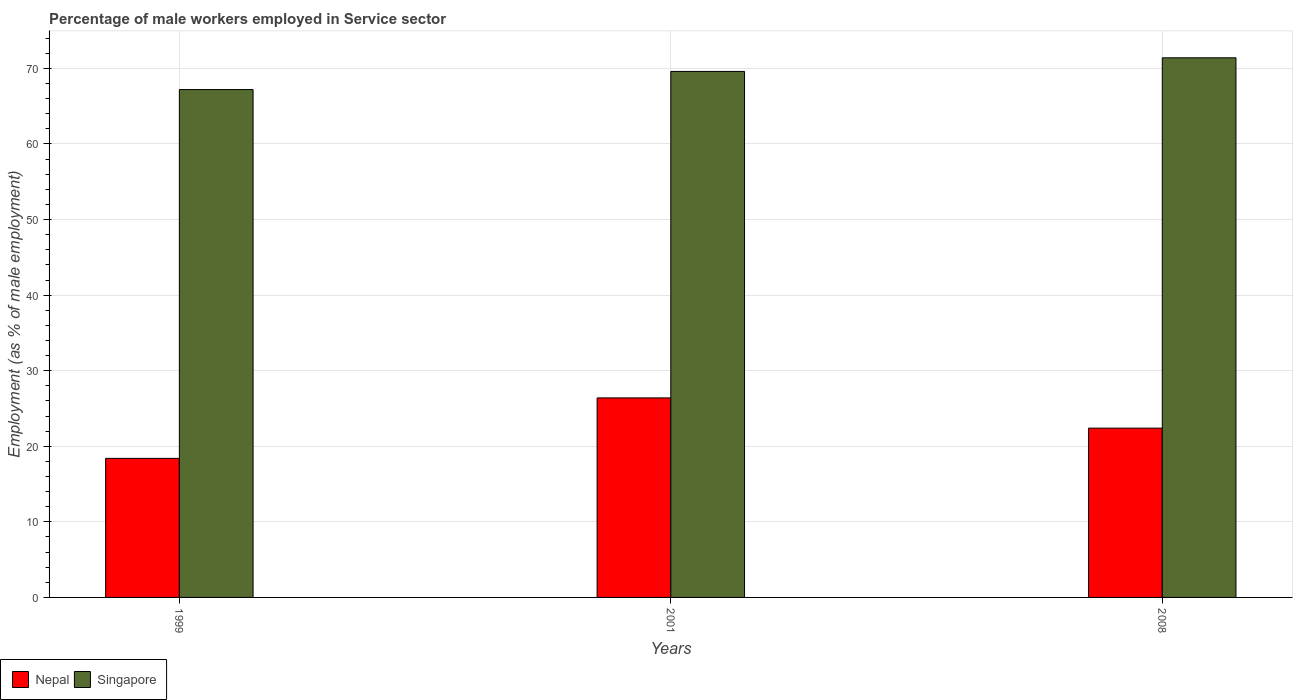How many groups of bars are there?
Your answer should be compact. 3. Are the number of bars per tick equal to the number of legend labels?
Keep it short and to the point. Yes. Are the number of bars on each tick of the X-axis equal?
Keep it short and to the point. Yes. How many bars are there on the 2nd tick from the left?
Offer a very short reply. 2. In how many cases, is the number of bars for a given year not equal to the number of legend labels?
Your answer should be very brief. 0. What is the percentage of male workers employed in Service sector in Nepal in 2001?
Provide a short and direct response. 26.4. Across all years, what is the maximum percentage of male workers employed in Service sector in Nepal?
Your answer should be very brief. 26.4. Across all years, what is the minimum percentage of male workers employed in Service sector in Nepal?
Your answer should be compact. 18.4. In which year was the percentage of male workers employed in Service sector in Nepal maximum?
Give a very brief answer. 2001. In which year was the percentage of male workers employed in Service sector in Nepal minimum?
Make the answer very short. 1999. What is the total percentage of male workers employed in Service sector in Singapore in the graph?
Ensure brevity in your answer.  208.2. What is the difference between the percentage of male workers employed in Service sector in Singapore in 2008 and the percentage of male workers employed in Service sector in Nepal in 1999?
Your answer should be very brief. 53. What is the average percentage of male workers employed in Service sector in Singapore per year?
Make the answer very short. 69.4. In the year 2001, what is the difference between the percentage of male workers employed in Service sector in Nepal and percentage of male workers employed in Service sector in Singapore?
Give a very brief answer. -43.2. What is the ratio of the percentage of male workers employed in Service sector in Nepal in 2001 to that in 2008?
Offer a terse response. 1.18. Is the percentage of male workers employed in Service sector in Nepal in 1999 less than that in 2001?
Provide a short and direct response. Yes. Is the difference between the percentage of male workers employed in Service sector in Nepal in 2001 and 2008 greater than the difference between the percentage of male workers employed in Service sector in Singapore in 2001 and 2008?
Make the answer very short. Yes. What is the difference between the highest and the second highest percentage of male workers employed in Service sector in Nepal?
Provide a short and direct response. 4. What is the difference between the highest and the lowest percentage of male workers employed in Service sector in Nepal?
Offer a terse response. 8. What does the 1st bar from the left in 2001 represents?
Give a very brief answer. Nepal. What does the 1st bar from the right in 2001 represents?
Give a very brief answer. Singapore. How many bars are there?
Your response must be concise. 6. Are all the bars in the graph horizontal?
Provide a short and direct response. No. How many years are there in the graph?
Provide a short and direct response. 3. Where does the legend appear in the graph?
Your response must be concise. Bottom left. How many legend labels are there?
Provide a short and direct response. 2. How are the legend labels stacked?
Keep it short and to the point. Horizontal. What is the title of the graph?
Give a very brief answer. Percentage of male workers employed in Service sector. Does "Singapore" appear as one of the legend labels in the graph?
Ensure brevity in your answer.  Yes. What is the label or title of the Y-axis?
Your answer should be compact. Employment (as % of male employment). What is the Employment (as % of male employment) of Nepal in 1999?
Provide a succinct answer. 18.4. What is the Employment (as % of male employment) in Singapore in 1999?
Give a very brief answer. 67.2. What is the Employment (as % of male employment) of Nepal in 2001?
Offer a terse response. 26.4. What is the Employment (as % of male employment) of Singapore in 2001?
Your response must be concise. 69.6. What is the Employment (as % of male employment) in Nepal in 2008?
Ensure brevity in your answer.  22.4. What is the Employment (as % of male employment) in Singapore in 2008?
Your answer should be very brief. 71.4. Across all years, what is the maximum Employment (as % of male employment) of Nepal?
Provide a succinct answer. 26.4. Across all years, what is the maximum Employment (as % of male employment) of Singapore?
Your answer should be compact. 71.4. Across all years, what is the minimum Employment (as % of male employment) in Nepal?
Make the answer very short. 18.4. Across all years, what is the minimum Employment (as % of male employment) of Singapore?
Offer a terse response. 67.2. What is the total Employment (as % of male employment) of Nepal in the graph?
Your answer should be compact. 67.2. What is the total Employment (as % of male employment) of Singapore in the graph?
Ensure brevity in your answer.  208.2. What is the difference between the Employment (as % of male employment) of Nepal in 1999 and that in 2001?
Offer a terse response. -8. What is the difference between the Employment (as % of male employment) of Singapore in 1999 and that in 2001?
Your response must be concise. -2.4. What is the difference between the Employment (as % of male employment) in Nepal in 1999 and that in 2008?
Provide a succinct answer. -4. What is the difference between the Employment (as % of male employment) in Singapore in 1999 and that in 2008?
Your answer should be very brief. -4.2. What is the difference between the Employment (as % of male employment) of Nepal in 2001 and that in 2008?
Provide a succinct answer. 4. What is the difference between the Employment (as % of male employment) of Singapore in 2001 and that in 2008?
Provide a succinct answer. -1.8. What is the difference between the Employment (as % of male employment) of Nepal in 1999 and the Employment (as % of male employment) of Singapore in 2001?
Ensure brevity in your answer.  -51.2. What is the difference between the Employment (as % of male employment) in Nepal in 1999 and the Employment (as % of male employment) in Singapore in 2008?
Make the answer very short. -53. What is the difference between the Employment (as % of male employment) of Nepal in 2001 and the Employment (as % of male employment) of Singapore in 2008?
Ensure brevity in your answer.  -45. What is the average Employment (as % of male employment) of Nepal per year?
Give a very brief answer. 22.4. What is the average Employment (as % of male employment) in Singapore per year?
Make the answer very short. 69.4. In the year 1999, what is the difference between the Employment (as % of male employment) in Nepal and Employment (as % of male employment) in Singapore?
Your answer should be compact. -48.8. In the year 2001, what is the difference between the Employment (as % of male employment) of Nepal and Employment (as % of male employment) of Singapore?
Your answer should be compact. -43.2. In the year 2008, what is the difference between the Employment (as % of male employment) of Nepal and Employment (as % of male employment) of Singapore?
Keep it short and to the point. -49. What is the ratio of the Employment (as % of male employment) of Nepal in 1999 to that in 2001?
Give a very brief answer. 0.7. What is the ratio of the Employment (as % of male employment) of Singapore in 1999 to that in 2001?
Give a very brief answer. 0.97. What is the ratio of the Employment (as % of male employment) in Nepal in 1999 to that in 2008?
Your answer should be very brief. 0.82. What is the ratio of the Employment (as % of male employment) in Nepal in 2001 to that in 2008?
Ensure brevity in your answer.  1.18. What is the ratio of the Employment (as % of male employment) of Singapore in 2001 to that in 2008?
Give a very brief answer. 0.97. What is the difference between the highest and the second highest Employment (as % of male employment) of Nepal?
Your answer should be very brief. 4. What is the difference between the highest and the second highest Employment (as % of male employment) in Singapore?
Ensure brevity in your answer.  1.8. 